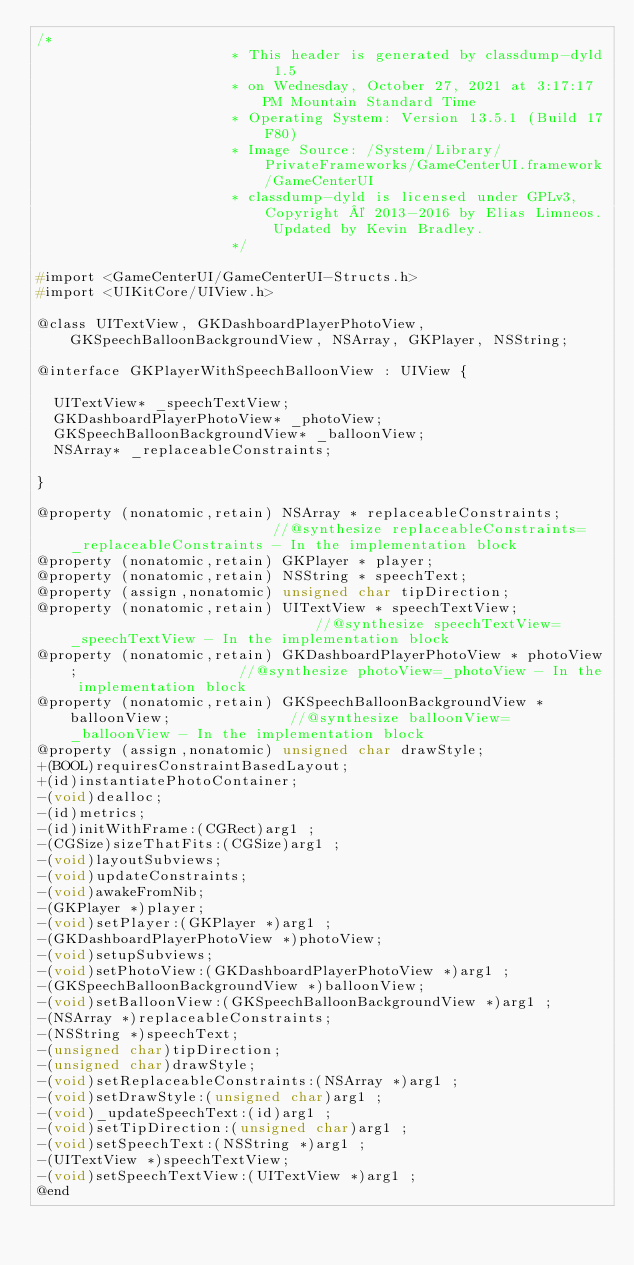Convert code to text. <code><loc_0><loc_0><loc_500><loc_500><_C_>/*
                       * This header is generated by classdump-dyld 1.5
                       * on Wednesday, October 27, 2021 at 3:17:17 PM Mountain Standard Time
                       * Operating System: Version 13.5.1 (Build 17F80)
                       * Image Source: /System/Library/PrivateFrameworks/GameCenterUI.framework/GameCenterUI
                       * classdump-dyld is licensed under GPLv3, Copyright © 2013-2016 by Elias Limneos. Updated by Kevin Bradley.
                       */

#import <GameCenterUI/GameCenterUI-Structs.h>
#import <UIKitCore/UIView.h>

@class UITextView, GKDashboardPlayerPhotoView, GKSpeechBalloonBackgroundView, NSArray, GKPlayer, NSString;

@interface GKPlayerWithSpeechBalloonView : UIView {

	UITextView* _speechTextView;
	GKDashboardPlayerPhotoView* _photoView;
	GKSpeechBalloonBackgroundView* _balloonView;
	NSArray* _replaceableConstraints;

}

@property (nonatomic,retain) NSArray * replaceableConstraints;                         //@synthesize replaceableConstraints=_replaceableConstraints - In the implementation block
@property (nonatomic,retain) GKPlayer * player; 
@property (nonatomic,retain) NSString * speechText; 
@property (assign,nonatomic) unsigned char tipDirection; 
@property (nonatomic,retain) UITextView * speechTextView;                              //@synthesize speechTextView=_speechTextView - In the implementation block
@property (nonatomic,retain) GKDashboardPlayerPhotoView * photoView;                   //@synthesize photoView=_photoView - In the implementation block
@property (nonatomic,retain) GKSpeechBalloonBackgroundView * balloonView;              //@synthesize balloonView=_balloonView - In the implementation block
@property (assign,nonatomic) unsigned char drawStyle; 
+(BOOL)requiresConstraintBasedLayout;
+(id)instantiatePhotoContainer;
-(void)dealloc;
-(id)metrics;
-(id)initWithFrame:(CGRect)arg1 ;
-(CGSize)sizeThatFits:(CGSize)arg1 ;
-(void)layoutSubviews;
-(void)updateConstraints;
-(void)awakeFromNib;
-(GKPlayer *)player;
-(void)setPlayer:(GKPlayer *)arg1 ;
-(GKDashboardPlayerPhotoView *)photoView;
-(void)setupSubviews;
-(void)setPhotoView:(GKDashboardPlayerPhotoView *)arg1 ;
-(GKSpeechBalloonBackgroundView *)balloonView;
-(void)setBalloonView:(GKSpeechBalloonBackgroundView *)arg1 ;
-(NSArray *)replaceableConstraints;
-(NSString *)speechText;
-(unsigned char)tipDirection;
-(unsigned char)drawStyle;
-(void)setReplaceableConstraints:(NSArray *)arg1 ;
-(void)setDrawStyle:(unsigned char)arg1 ;
-(void)_updateSpeechText:(id)arg1 ;
-(void)setTipDirection:(unsigned char)arg1 ;
-(void)setSpeechText:(NSString *)arg1 ;
-(UITextView *)speechTextView;
-(void)setSpeechTextView:(UITextView *)arg1 ;
@end

</code> 